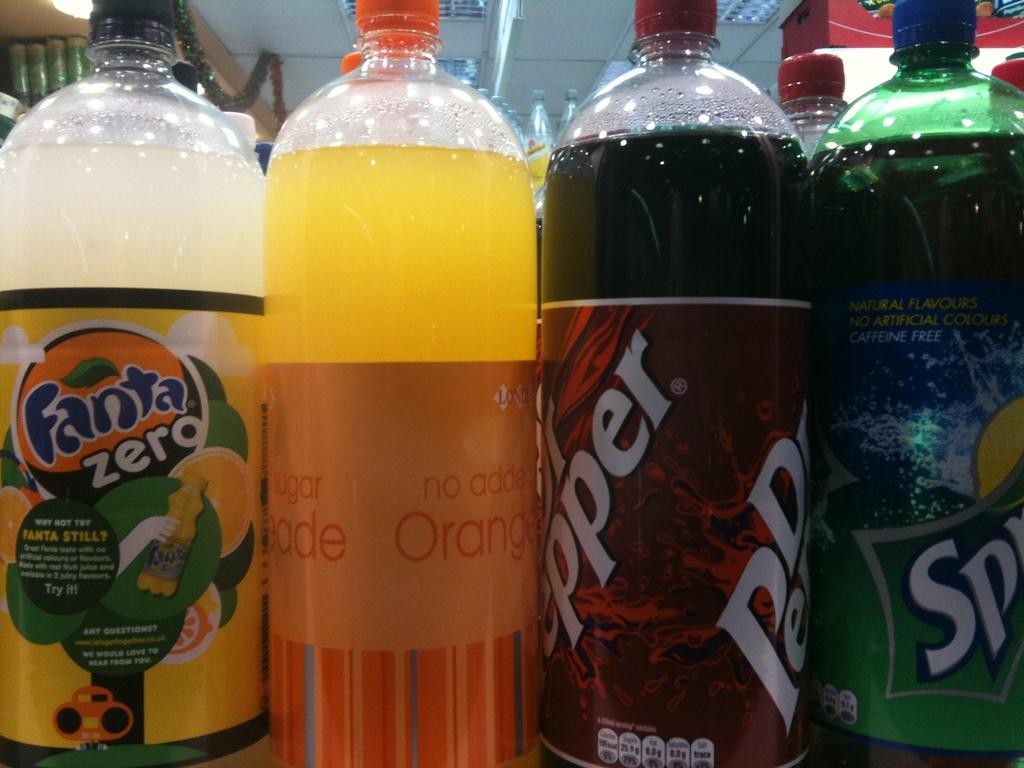Provide a one-sentence caption for the provided image. A group of soda bottles are close to each other including Sprite, and Dr. Pepper. 